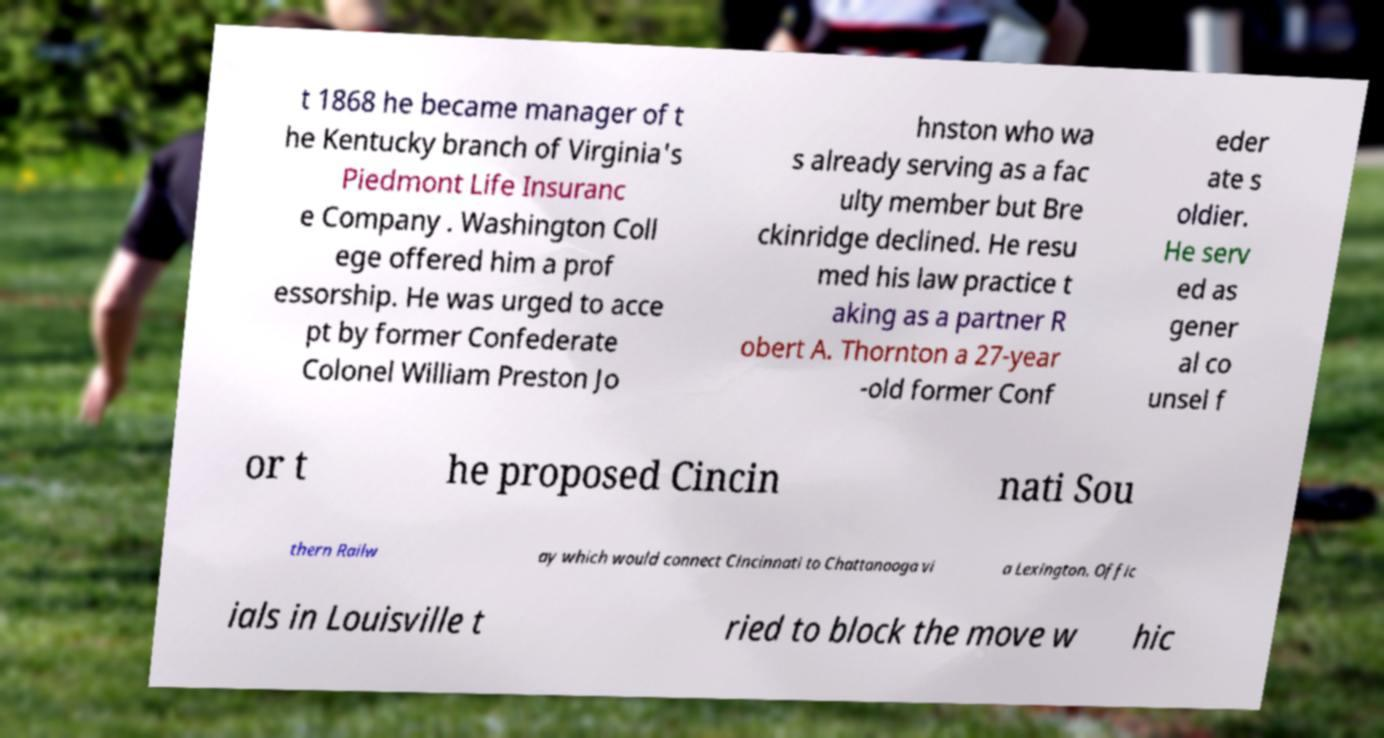Can you read and provide the text displayed in the image?This photo seems to have some interesting text. Can you extract and type it out for me? t 1868 he became manager of t he Kentucky branch of Virginia's Piedmont Life Insuranc e Company . Washington Coll ege offered him a prof essorship. He was urged to acce pt by former Confederate Colonel William Preston Jo hnston who wa s already serving as a fac ulty member but Bre ckinridge declined. He resu med his law practice t aking as a partner R obert A. Thornton a 27-year -old former Conf eder ate s oldier. He serv ed as gener al co unsel f or t he proposed Cincin nati Sou thern Railw ay which would connect Cincinnati to Chattanooga vi a Lexington. Offic ials in Louisville t ried to block the move w hic 